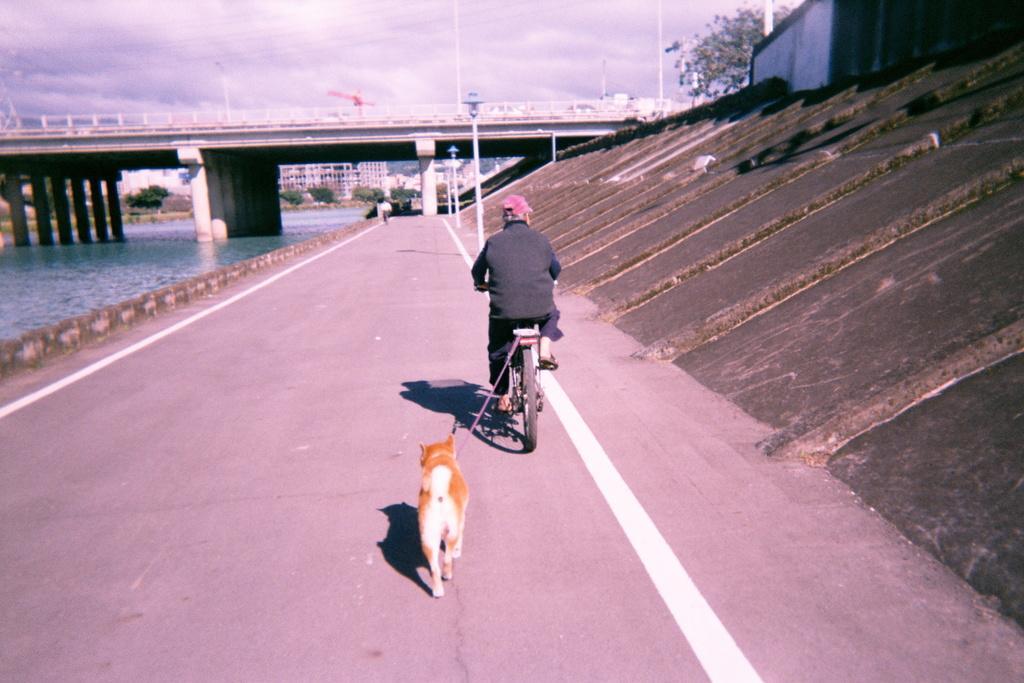Please provide a concise description of this image. In this picture I can see a man riding bicycle and a dog is tied to the bicycle with the help of a string and I can see a bridge and water and few buildings, trees and few pole lights and a crane and I can see a cloudy sky, 